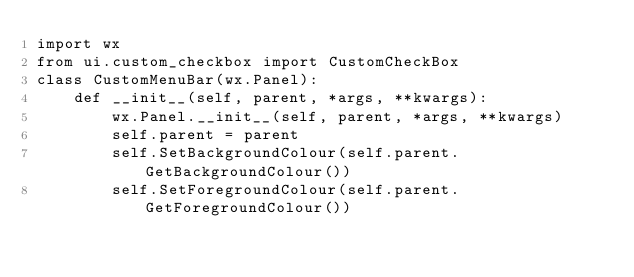Convert code to text. <code><loc_0><loc_0><loc_500><loc_500><_Python_>import wx
from ui.custom_checkbox import CustomCheckBox
class CustomMenuBar(wx.Panel):
    def __init__(self, parent, *args, **kwargs):
        wx.Panel.__init__(self, parent, *args, **kwargs)
        self.parent = parent
        self.SetBackgroundColour(self.parent.GetBackgroundColour())
        self.SetForegroundColour(self.parent.GetForegroundColour())</code> 